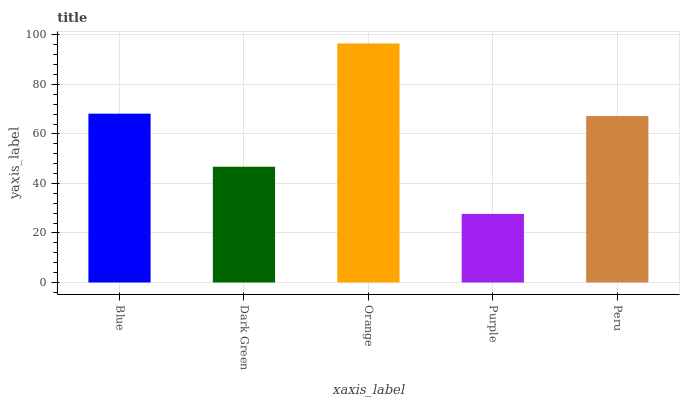Is Purple the minimum?
Answer yes or no. Yes. Is Orange the maximum?
Answer yes or no. Yes. Is Dark Green the minimum?
Answer yes or no. No. Is Dark Green the maximum?
Answer yes or no. No. Is Blue greater than Dark Green?
Answer yes or no. Yes. Is Dark Green less than Blue?
Answer yes or no. Yes. Is Dark Green greater than Blue?
Answer yes or no. No. Is Blue less than Dark Green?
Answer yes or no. No. Is Peru the high median?
Answer yes or no. Yes. Is Peru the low median?
Answer yes or no. Yes. Is Blue the high median?
Answer yes or no. No. Is Purple the low median?
Answer yes or no. No. 